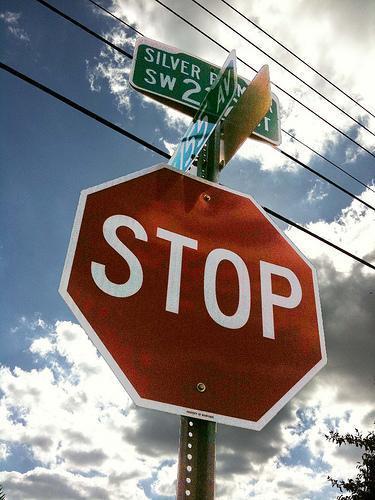How many signs are visible?
Give a very brief answer. 4. 